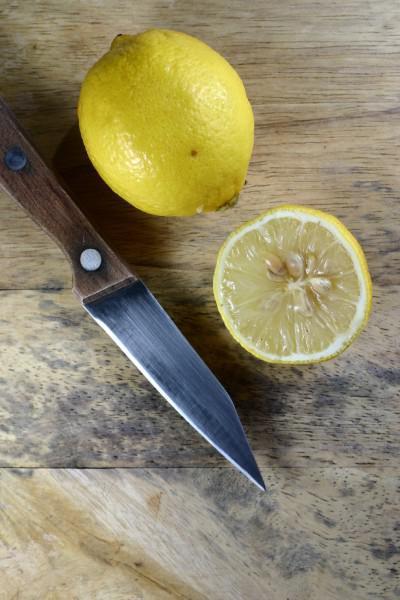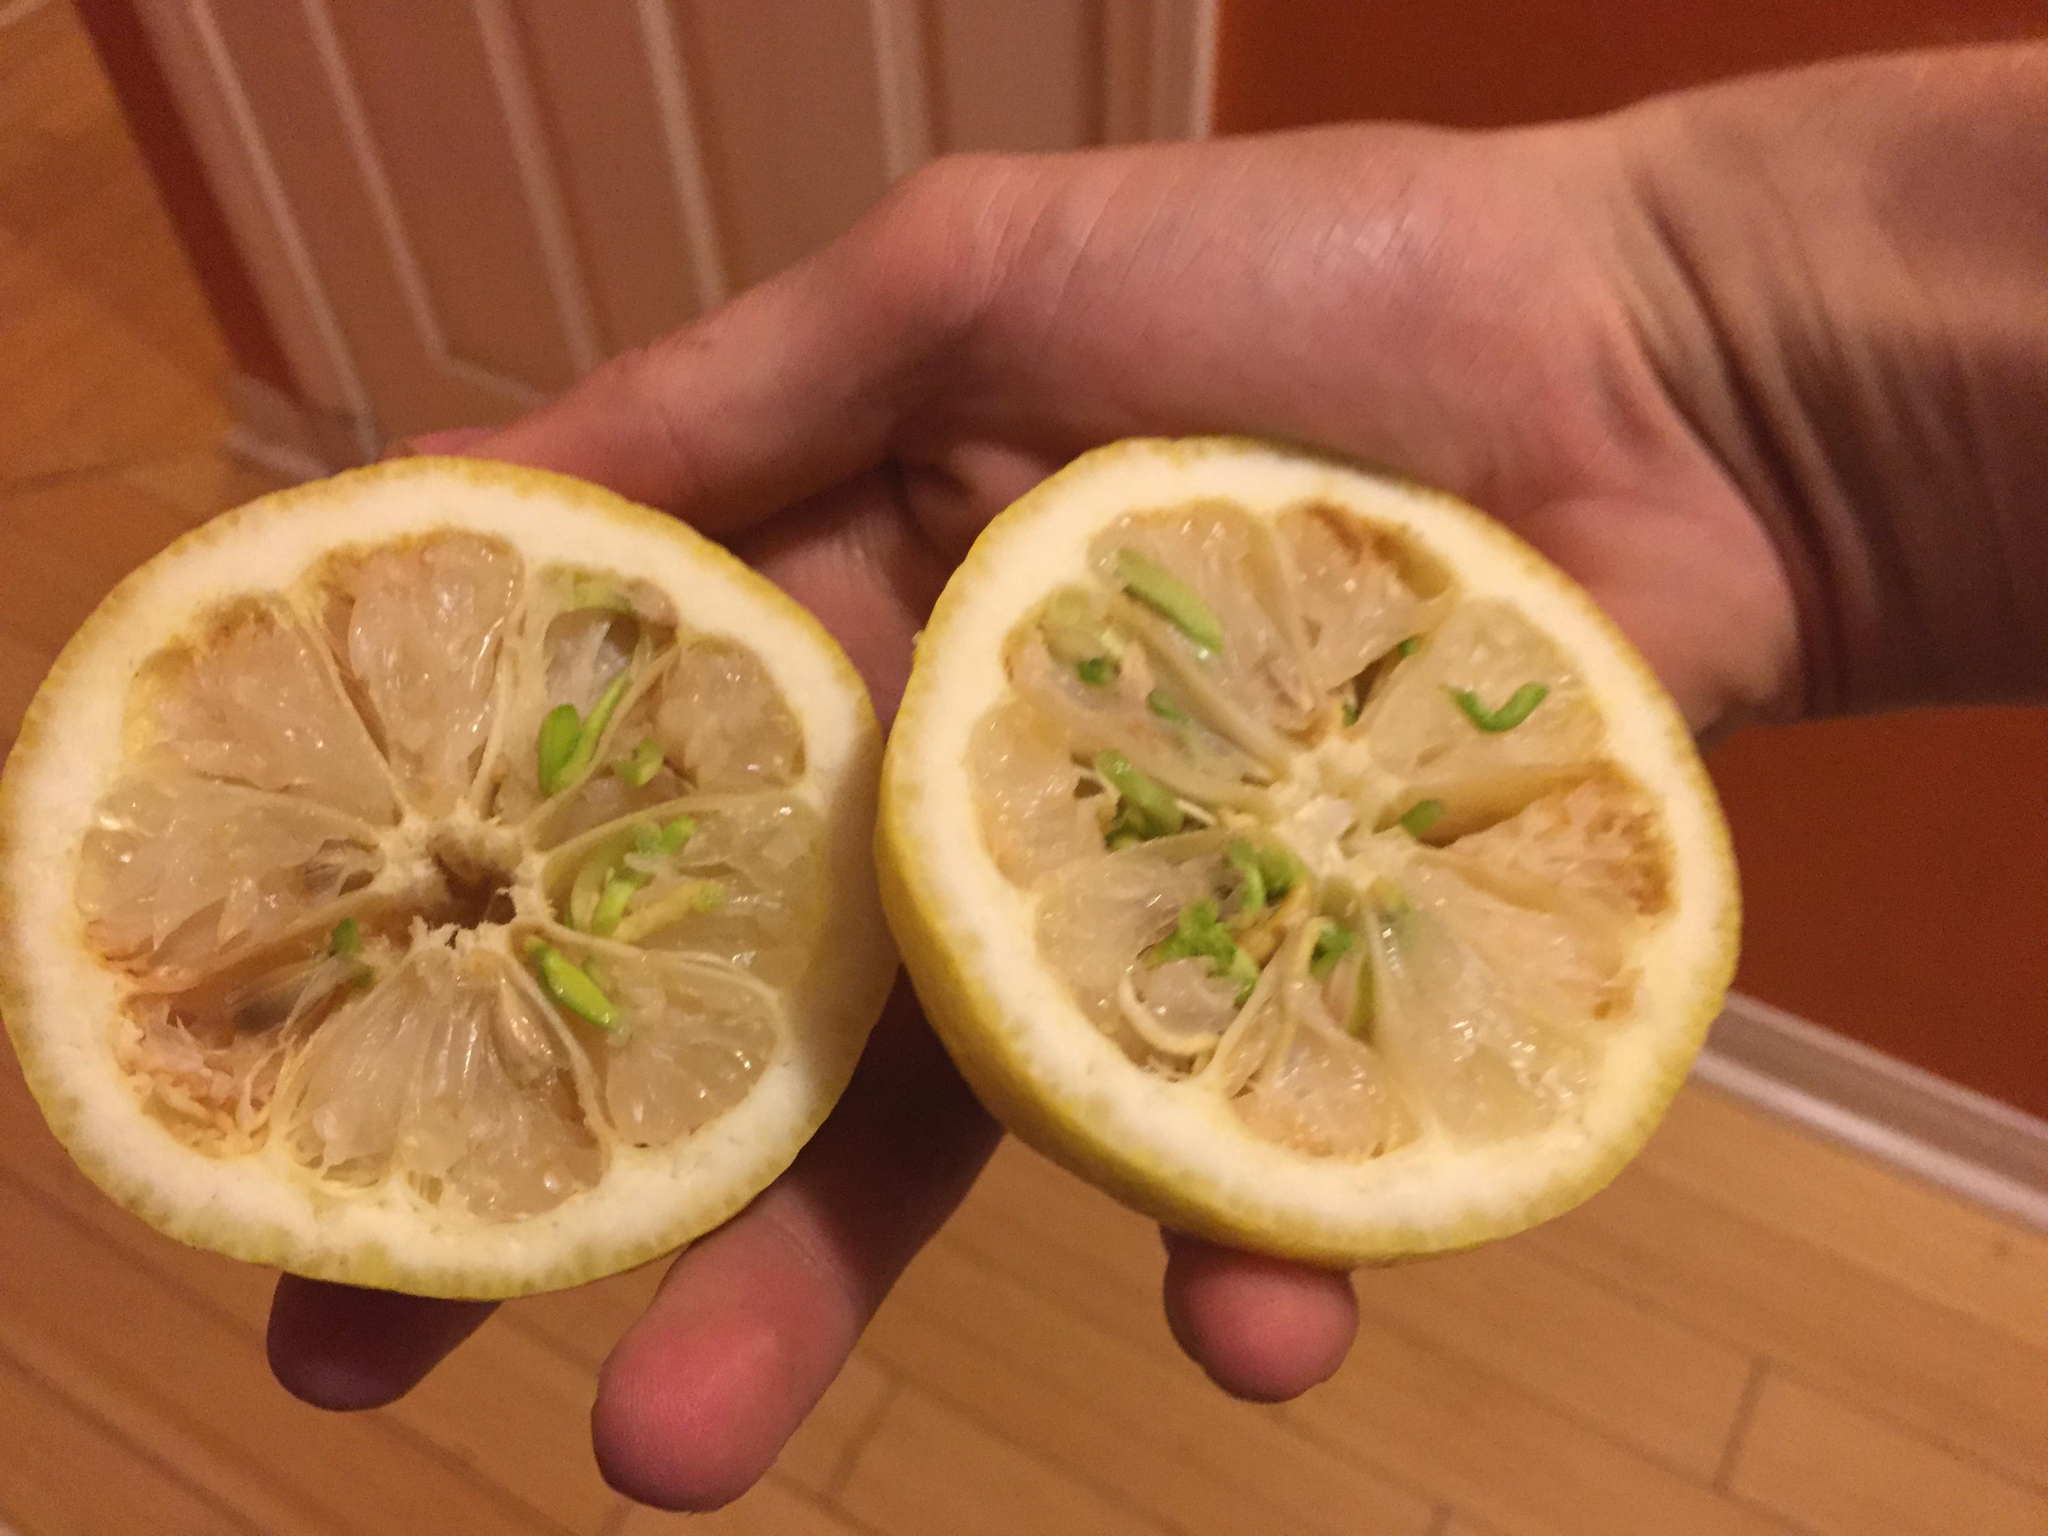The first image is the image on the left, the second image is the image on the right. Given the left and right images, does the statement "An image includes a knife beside a lemon cut in half on a wooden cutting surface." hold true? Answer yes or no. Yes. 